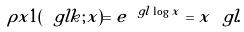<formula> <loc_0><loc_0><loc_500><loc_500>\rho x 1 ( \ g l k ; x ) = e ^ { \ g l \log x } = x ^ { \ } g l .</formula> 